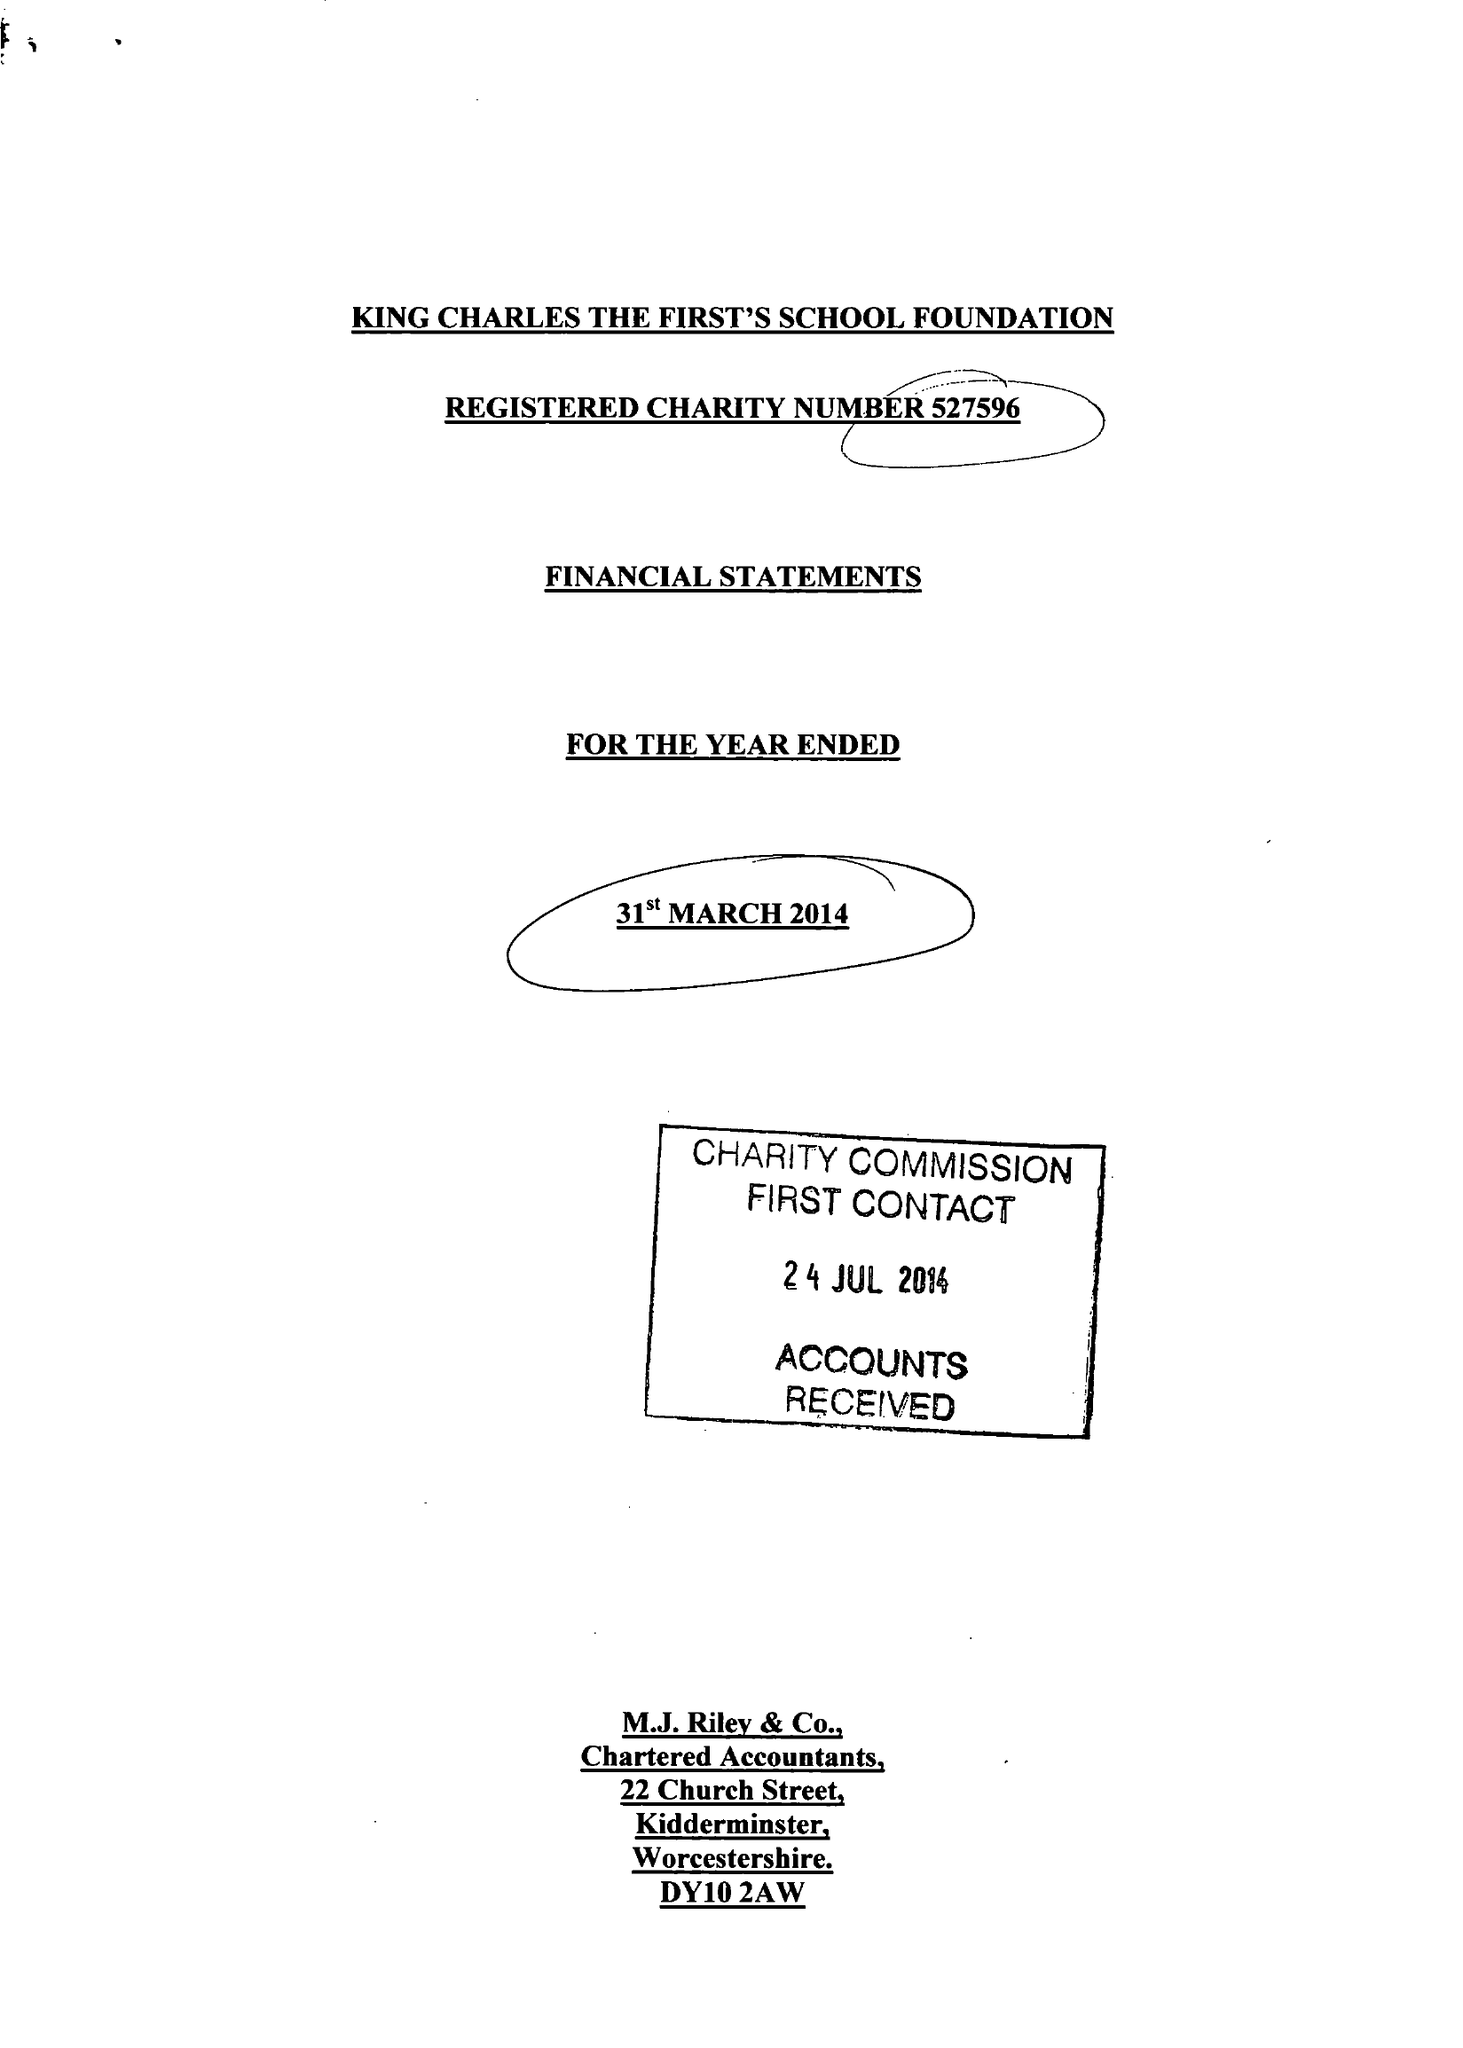What is the value for the address__post_town?
Answer the question using a single word or phrase. STOURPORT-ON-SEVERN 